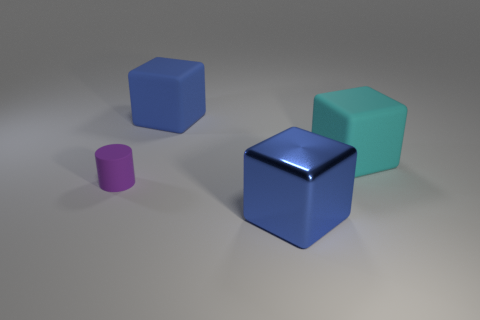Subtract all big blue metallic blocks. How many blocks are left? 2 Subtract all brown spheres. How many blue blocks are left? 2 Add 2 big blue rubber objects. How many objects exist? 6 Subtract all blocks. How many objects are left? 1 Add 1 big cyan rubber things. How many big cyan rubber things exist? 2 Subtract 0 yellow spheres. How many objects are left? 4 Subtract all large red matte blocks. Subtract all metal things. How many objects are left? 3 Add 1 purple rubber objects. How many purple rubber objects are left? 2 